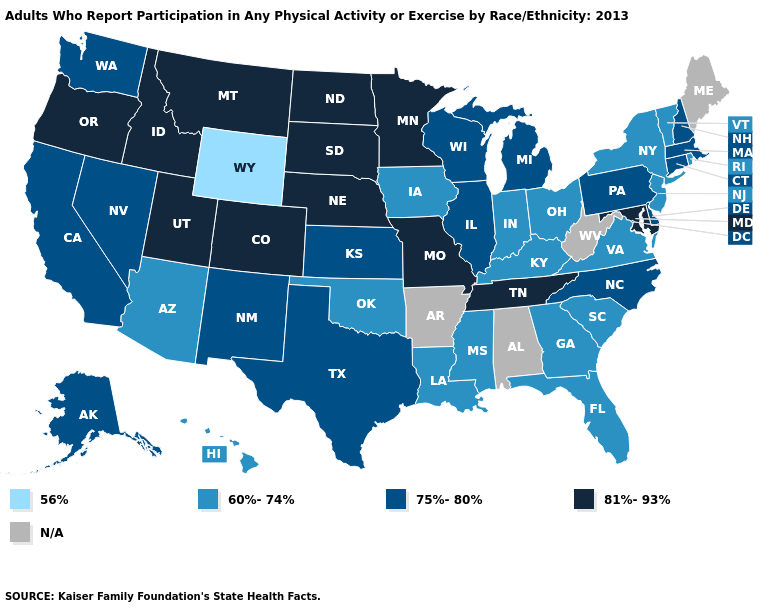Which states hav the highest value in the West?
Concise answer only. Colorado, Idaho, Montana, Oregon, Utah. Does the first symbol in the legend represent the smallest category?
Give a very brief answer. Yes. Does the map have missing data?
Be succinct. Yes. Among the states that border Idaho , does Wyoming have the lowest value?
Concise answer only. Yes. What is the value of South Carolina?
Short answer required. 60%-74%. Does Washington have the highest value in the West?
Give a very brief answer. No. Is the legend a continuous bar?
Short answer required. No. What is the value of Nebraska?
Give a very brief answer. 81%-93%. What is the value of Michigan?
Quick response, please. 75%-80%. Name the states that have a value in the range 75%-80%?
Concise answer only. Alaska, California, Connecticut, Delaware, Illinois, Kansas, Massachusetts, Michigan, Nevada, New Hampshire, New Mexico, North Carolina, Pennsylvania, Texas, Washington, Wisconsin. How many symbols are there in the legend?
Be succinct. 5. Name the states that have a value in the range 60%-74%?
Concise answer only. Arizona, Florida, Georgia, Hawaii, Indiana, Iowa, Kentucky, Louisiana, Mississippi, New Jersey, New York, Ohio, Oklahoma, Rhode Island, South Carolina, Vermont, Virginia. Does California have the highest value in the West?
Concise answer only. No. Which states have the lowest value in the West?
Keep it brief. Wyoming. 